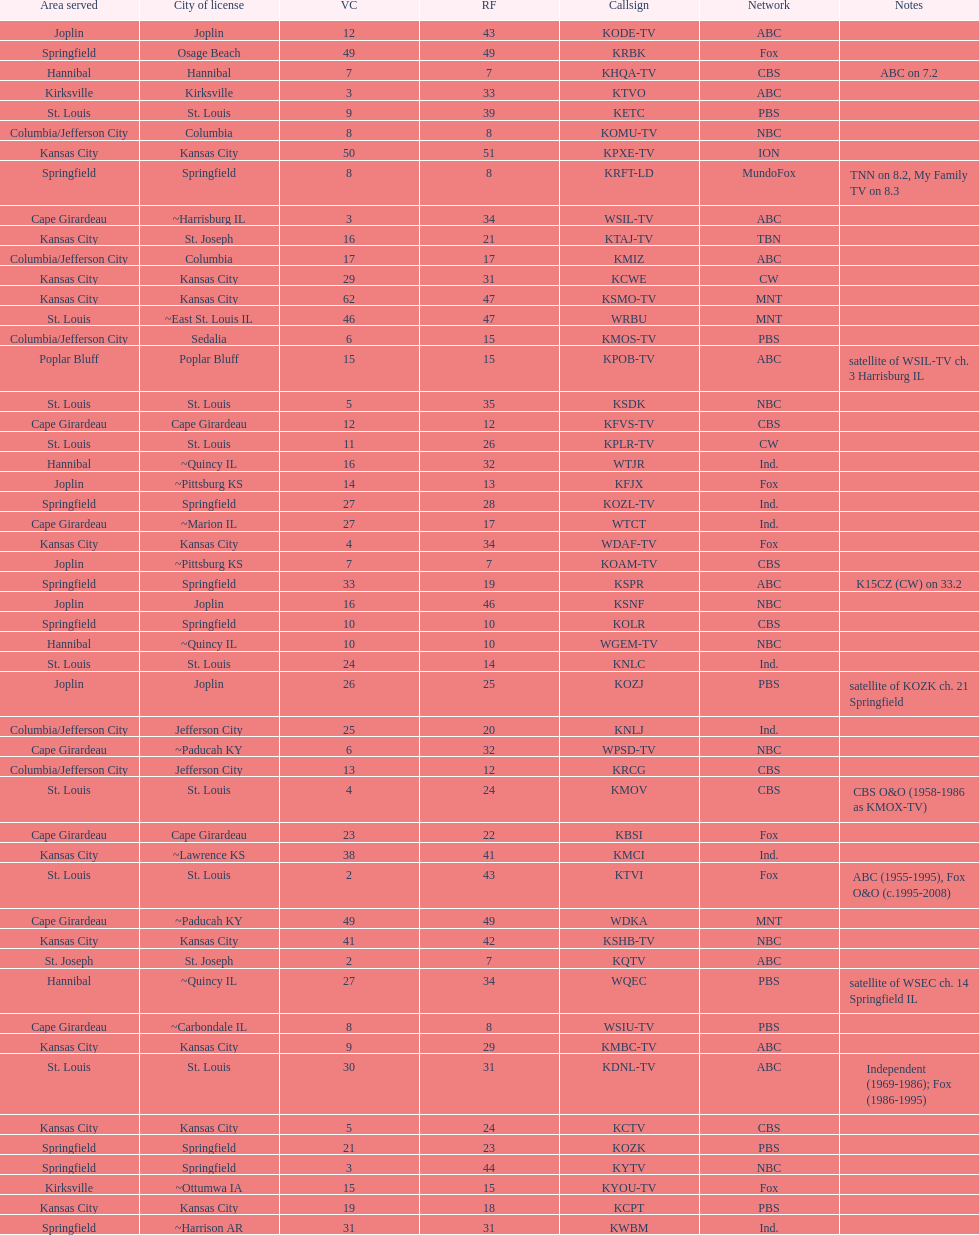Kode-tv and wsil-tv both are a part of which network? ABC. 